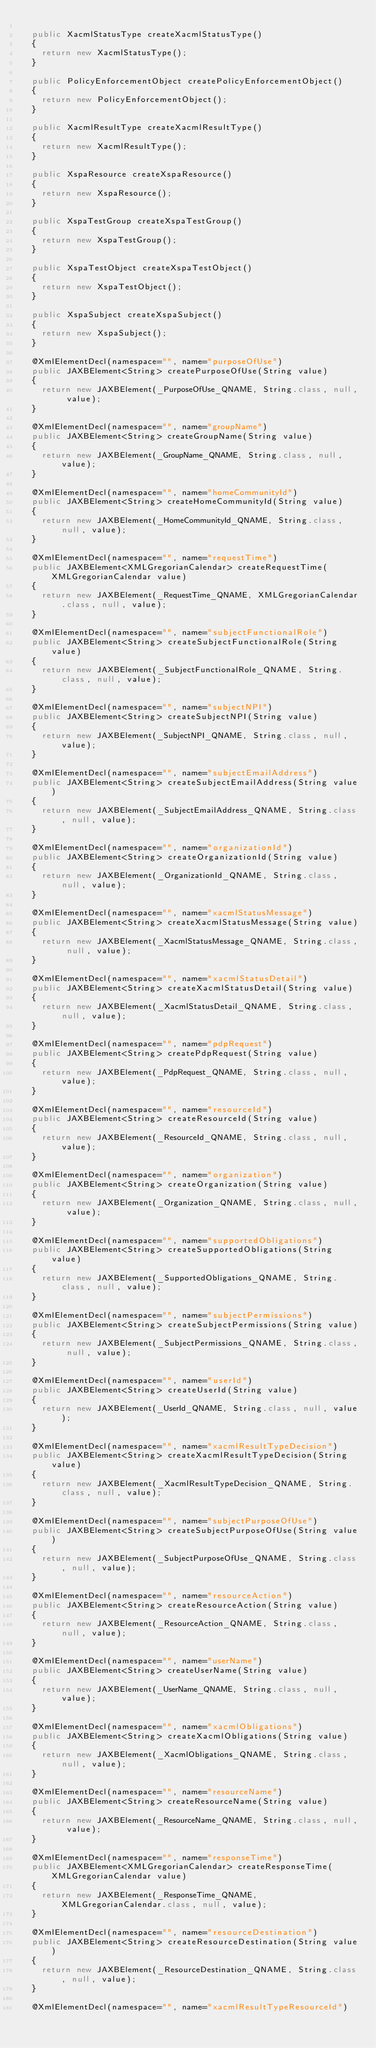Convert code to text. <code><loc_0><loc_0><loc_500><loc_500><_Java_>
  public XacmlStatusType createXacmlStatusType()
  {
    return new XacmlStatusType();
  }

  public PolicyEnforcementObject createPolicyEnforcementObject()
  {
    return new PolicyEnforcementObject();
  }

  public XacmlResultType createXacmlResultType()
  {
    return new XacmlResultType();
  }

  public XspaResource createXspaResource()
  {
    return new XspaResource();
  }

  public XspaTestGroup createXspaTestGroup()
  {
    return new XspaTestGroup();
  }

  public XspaTestObject createXspaTestObject()
  {
    return new XspaTestObject();
  }

  public XspaSubject createXspaSubject()
  {
    return new XspaSubject();
  }

  @XmlElementDecl(namespace="", name="purposeOfUse")
  public JAXBElement<String> createPurposeOfUse(String value)
  {
    return new JAXBElement(_PurposeOfUse_QNAME, String.class, null, value);
  }

  @XmlElementDecl(namespace="", name="groupName")
  public JAXBElement<String> createGroupName(String value)
  {
    return new JAXBElement(_GroupName_QNAME, String.class, null, value);
  }

  @XmlElementDecl(namespace="", name="homeCommunityId")
  public JAXBElement<String> createHomeCommunityId(String value)
  {
    return new JAXBElement(_HomeCommunityId_QNAME, String.class, null, value);
  }

  @XmlElementDecl(namespace="", name="requestTime")
  public JAXBElement<XMLGregorianCalendar> createRequestTime(XMLGregorianCalendar value)
  {
    return new JAXBElement(_RequestTime_QNAME, XMLGregorianCalendar.class, null, value);
  }

  @XmlElementDecl(namespace="", name="subjectFunctionalRole")
  public JAXBElement<String> createSubjectFunctionalRole(String value)
  {
    return new JAXBElement(_SubjectFunctionalRole_QNAME, String.class, null, value);
  }

  @XmlElementDecl(namespace="", name="subjectNPI")
  public JAXBElement<String> createSubjectNPI(String value)
  {
    return new JAXBElement(_SubjectNPI_QNAME, String.class, null, value);
  }

  @XmlElementDecl(namespace="", name="subjectEmailAddress")
  public JAXBElement<String> createSubjectEmailAddress(String value)
  {
    return new JAXBElement(_SubjectEmailAddress_QNAME, String.class, null, value);
  }

  @XmlElementDecl(namespace="", name="organizationId")
  public JAXBElement<String> createOrganizationId(String value)
  {
    return new JAXBElement(_OrganizationId_QNAME, String.class, null, value);
  }

  @XmlElementDecl(namespace="", name="xacmlStatusMessage")
  public JAXBElement<String> createXacmlStatusMessage(String value)
  {
    return new JAXBElement(_XacmlStatusMessage_QNAME, String.class, null, value);
  }

  @XmlElementDecl(namespace="", name="xacmlStatusDetail")
  public JAXBElement<String> createXacmlStatusDetail(String value)
  {
    return new JAXBElement(_XacmlStatusDetail_QNAME, String.class, null, value);
  }

  @XmlElementDecl(namespace="", name="pdpRequest")
  public JAXBElement<String> createPdpRequest(String value)
  {
    return new JAXBElement(_PdpRequest_QNAME, String.class, null, value);
  }

  @XmlElementDecl(namespace="", name="resourceId")
  public JAXBElement<String> createResourceId(String value)
  {
    return new JAXBElement(_ResourceId_QNAME, String.class, null, value);
  }

  @XmlElementDecl(namespace="", name="organization")
  public JAXBElement<String> createOrganization(String value)
  {
    return new JAXBElement(_Organization_QNAME, String.class, null, value);
  }

  @XmlElementDecl(namespace="", name="supportedObligations")
  public JAXBElement<String> createSupportedObligations(String value)
  {
    return new JAXBElement(_SupportedObligations_QNAME, String.class, null, value);
  }

  @XmlElementDecl(namespace="", name="subjectPermissions")
  public JAXBElement<String> createSubjectPermissions(String value)
  {
    return new JAXBElement(_SubjectPermissions_QNAME, String.class, null, value);
  }

  @XmlElementDecl(namespace="", name="userId")
  public JAXBElement<String> createUserId(String value)
  {
    return new JAXBElement(_UserId_QNAME, String.class, null, value);
  }

  @XmlElementDecl(namespace="", name="xacmlResultTypeDecision")
  public JAXBElement<String> createXacmlResultTypeDecision(String value)
  {
    return new JAXBElement(_XacmlResultTypeDecision_QNAME, String.class, null, value);
  }

  @XmlElementDecl(namespace="", name="subjectPurposeOfUse")
  public JAXBElement<String> createSubjectPurposeOfUse(String value)
  {
    return new JAXBElement(_SubjectPurposeOfUse_QNAME, String.class, null, value);
  }

  @XmlElementDecl(namespace="", name="resourceAction")
  public JAXBElement<String> createResourceAction(String value)
  {
    return new JAXBElement(_ResourceAction_QNAME, String.class, null, value);
  }

  @XmlElementDecl(namespace="", name="userName")
  public JAXBElement<String> createUserName(String value)
  {
    return new JAXBElement(_UserName_QNAME, String.class, null, value);
  }

  @XmlElementDecl(namespace="", name="xacmlObligations")
  public JAXBElement<String> createXacmlObligations(String value)
  {
    return new JAXBElement(_XacmlObligations_QNAME, String.class, null, value);
  }

  @XmlElementDecl(namespace="", name="resourceName")
  public JAXBElement<String> createResourceName(String value)
  {
    return new JAXBElement(_ResourceName_QNAME, String.class, null, value);
  }

  @XmlElementDecl(namespace="", name="responseTime")
  public JAXBElement<XMLGregorianCalendar> createResponseTime(XMLGregorianCalendar value)
  {
    return new JAXBElement(_ResponseTime_QNAME, XMLGregorianCalendar.class, null, value);
  }

  @XmlElementDecl(namespace="", name="resourceDestination")
  public JAXBElement<String> createResourceDestination(String value)
  {
    return new JAXBElement(_ResourceDestination_QNAME, String.class, null, value);
  }

  @XmlElementDecl(namespace="", name="xacmlResultTypeResourceId")</code> 